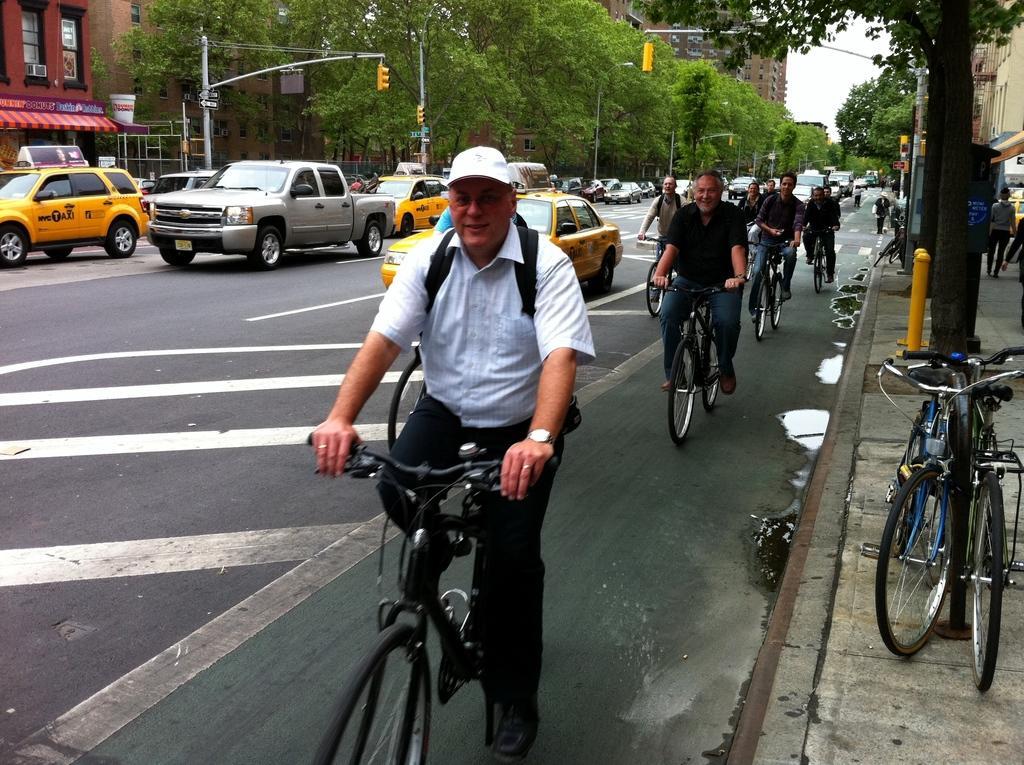Could you give a brief overview of what you see in this image? In this image there are group of people who are riding on a cycle on the right side. On the left side there are vehicles on the background there are trees and building and sky is there and on the top of the right corner there is another building and trees are there and on the bottom of the right corner there is footpath and on the footpath there are bicycles and on the left side there is one building and one tent and poles are there. In the middle of the image there is one person who is on a cycle and he is wearing white shirt and cap and he is wearing a watch. 